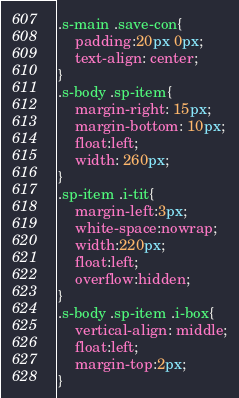Convert code to text. <code><loc_0><loc_0><loc_500><loc_500><_CSS_>.s-main .save-con{
    padding:20px 0px;
    text-align: center;
}
.s-body .sp-item{
    margin-right: 15px;
    margin-bottom: 10px;
    float:left;
    width: 260px;
}
.sp-item .i-tit{
    margin-left:3px;
    white-space:nowrap;
    width:220px;
    float:left;
    overflow:hidden;
}
.s-body .sp-item .i-box{
    vertical-align: middle;
    float:left;
    margin-top:2px;
}</code> 